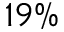<formula> <loc_0><loc_0><loc_500><loc_500>1 9 \%</formula> 